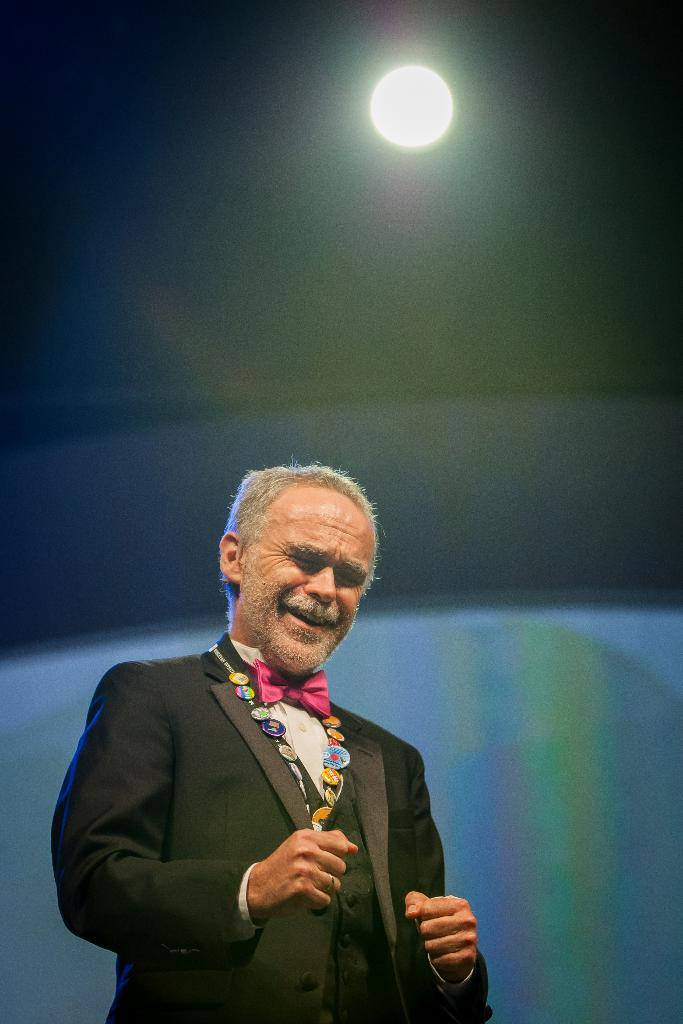Who is present in the image? There is a man in the image. What can be seen on the roof top? There is a light on the roof top. What is visible in the background of the image? There is an object in the background of the image. What type of stew is being prepared in the image? There is no indication of any food preparation or stew in the image. What reward is the man receiving in the image? There is no indication of a reward or any accomplishment in the image. 